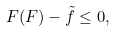Convert formula to latex. <formula><loc_0><loc_0><loc_500><loc_500>\ F ( F ) - \tilde { f } \leq 0 ,</formula> 